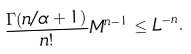Convert formula to latex. <formula><loc_0><loc_0><loc_500><loc_500>\frac { \Gamma ( n / \alpha + 1 ) } { n ! } M ^ { n - 1 } \leq L ^ { - n } .</formula> 